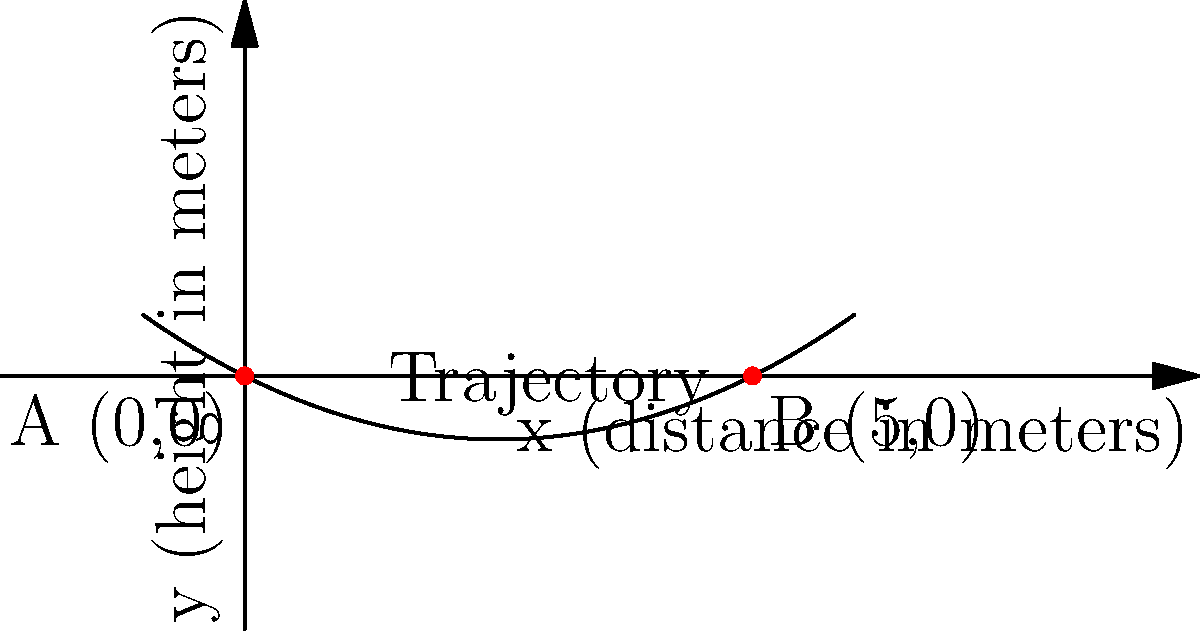A speeding vehicle launches off a ramp and follows a parabolic trajectory described by the equation $y = 0.1x^2 - 0.5x$, where $x$ and $y$ are measured in meters. The vehicle lands 5 meters away from the launch point. Calculate the maximum height reached by the vehicle during its trajectory. To find the maximum height of the trajectory, we need to follow these steps:

1) The parabola is given by $y = 0.1x^2 - 0.5x$

2) The vertex of a parabola represents its maximum or minimum point. For a parabola opening upward (positive coefficient of $x^2$), this point is the maximum.

3) For a parabola in the form $y = ax^2 + bx + c$, the x-coordinate of the vertex is given by $x = -\frac{b}{2a}$

4) In our case, $a = 0.1$ and $b = -0.5$. So:

   $x = -\frac{-0.5}{2(0.1)} = \frac{0.5}{0.2} = 2.5$

5) To find the y-coordinate (height) at this point, we substitute $x = 2.5$ into the original equation:

   $y = 0.1(2.5)^2 - 0.5(2.5)$
   $= 0.1(6.25) - 1.25$
   $= 0.625 - 1.25$
   $= -0.625$

6) Therefore, the maximum height is 0.625 meters above the launch point.
Answer: 0.625 meters 